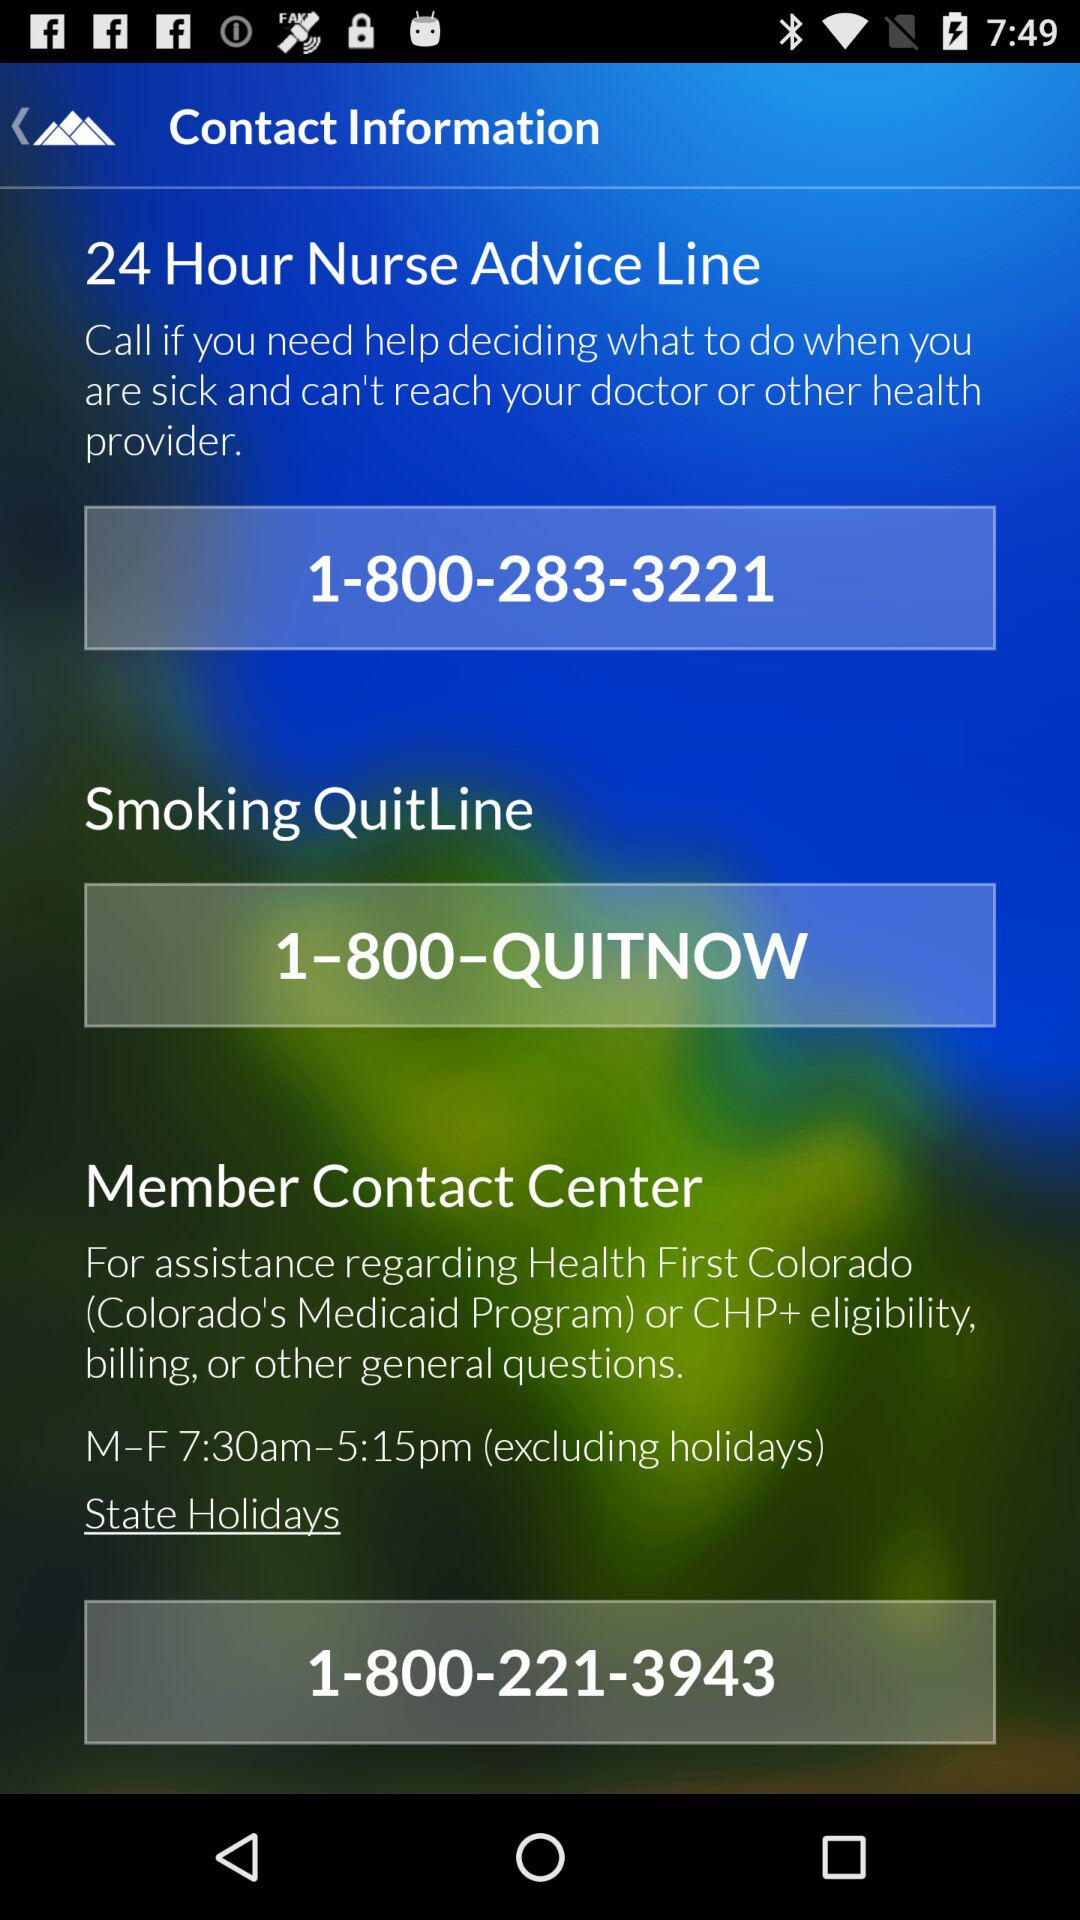How many of the contact numbers are for the Member Contact Center?
Answer the question using a single word or phrase. 1 